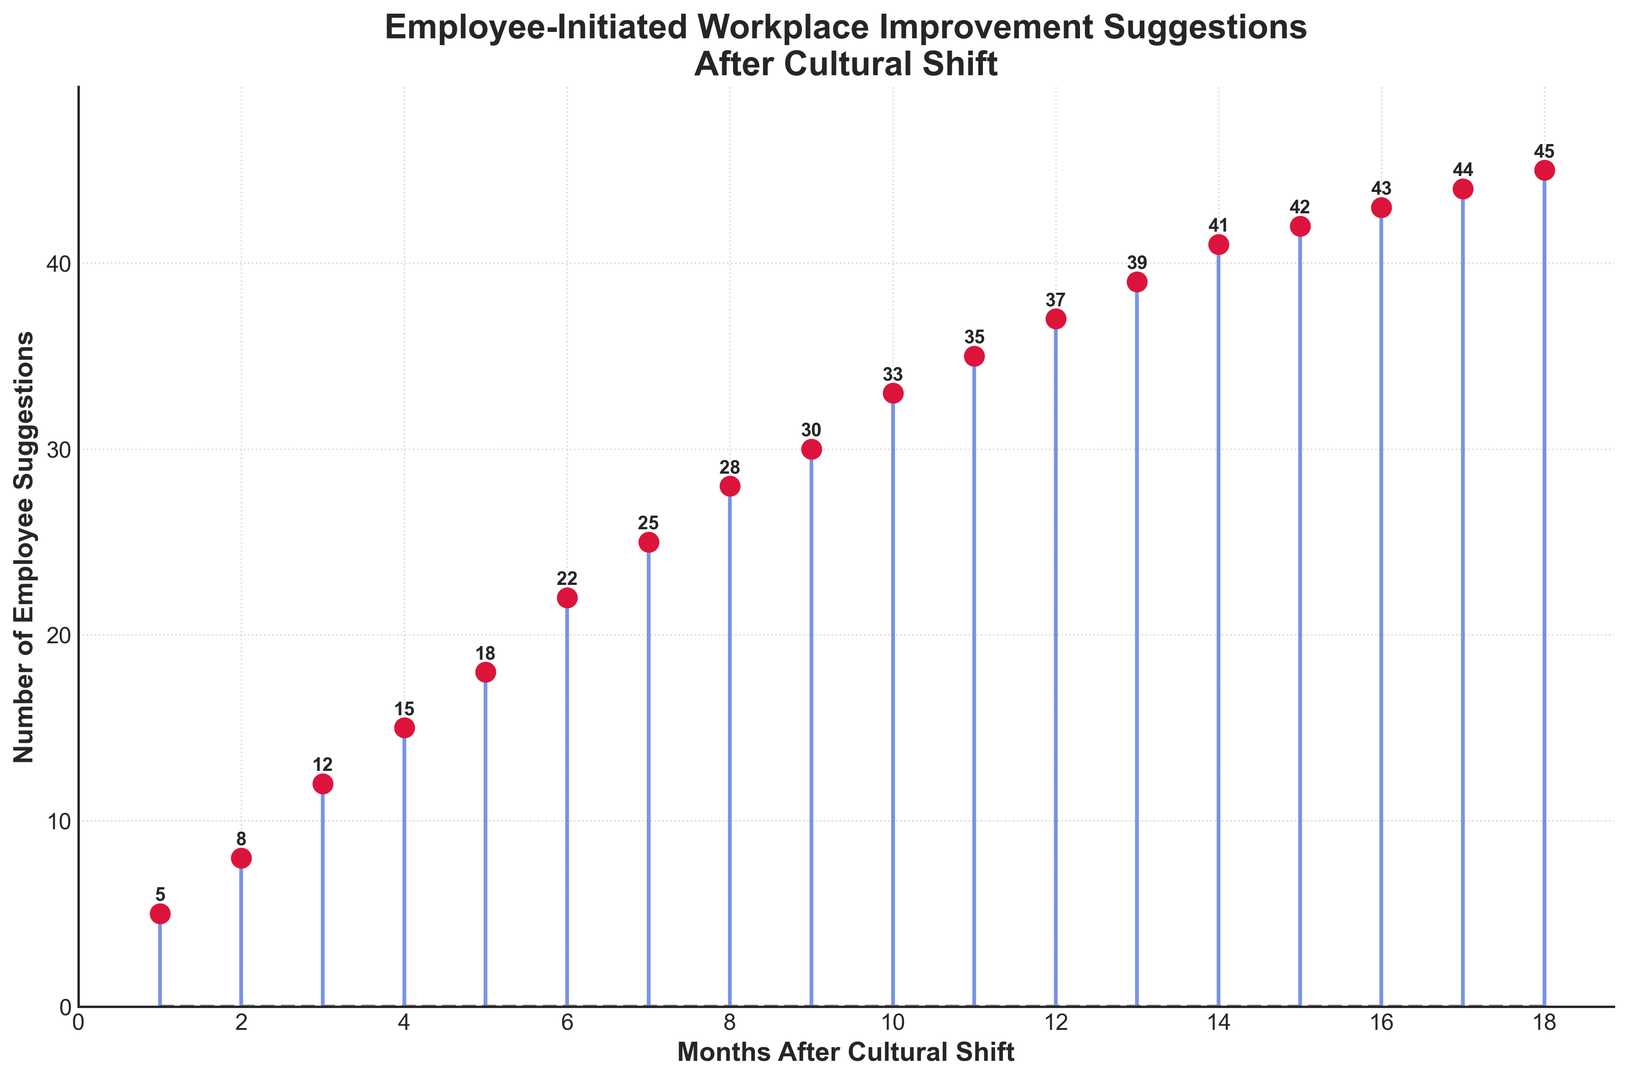How many suggestions were made in the first six months after the cultural shift? Sum the suggestions from months 1 to 6: 5 + 8 + 12 + 15 + 18 + 22
Answer: 80 By how much did the number of suggestions increase from the start to the 18th month? Subtract the number of suggestions in month 1 from the number in month 18: 45 - 5
Answer: 40 How many months saw suggestions equal to or greater than 30? Count the months where suggestions are ≥ 30: months 9, 10, 11, 12, 13, 14, 15, 16, 17, 18 (10 months)
Answer: 10 What's the average number of suggestions received per month over the entire period? Sum the suggestions and divide by the number of months: (5 + 8 + 12 + 15 + 18 + 22 + 25 + 28 + 30 + 33 + 35 + 37 + 39 + 41 + 42 + 43 + 44 + 45)/18. The total is 522, so 522 / 18 = 29
Answer: 29 Which month had the highest number of suggestions and how many? The 18th month had the highest number of suggestions at 45
Answer: Month 18, 45 What is the trend observed in the number of suggestions over the months? The number of suggestions shows a generally increasing trend over the 18 months, indicating a positive response to the cultural shift
Answer: Increasing How many months experienced an increase in suggestions from the previous month? Count the months where suggestions increased compared to the previous month: all subsequent months from month 2 to month 18 (17 months)
Answer: 17 What is the median number of suggestions over the 18 months? The 18 data points in ascending order are: 5, 8, 12, 15, 18, 22, 25, 28, 30, 33, 35, 37, 39, 41, 42, 43, 44, 45. The median is the middle value of these numbers, which is the average of the 9th and 10th values: (30 + 33)/2 = 31.5
Answer: 31.5 How did the number of suggestions change between the 10th and 15th month? Subtract the number of suggestions in month 10 from the number in month 15: 42 - 33
Answer: 9 Which month had the largest month-to-month increase in suggestions? Compare the difference in suggestions between each consecutive month. The largest increase is from month 6 to 7: 25 - 22 = 3
Answer: Month 7 What is the visual appearance of the baseline in the plot? The baseline is represented by a gray dashed line
Answer: Gray dashed line 